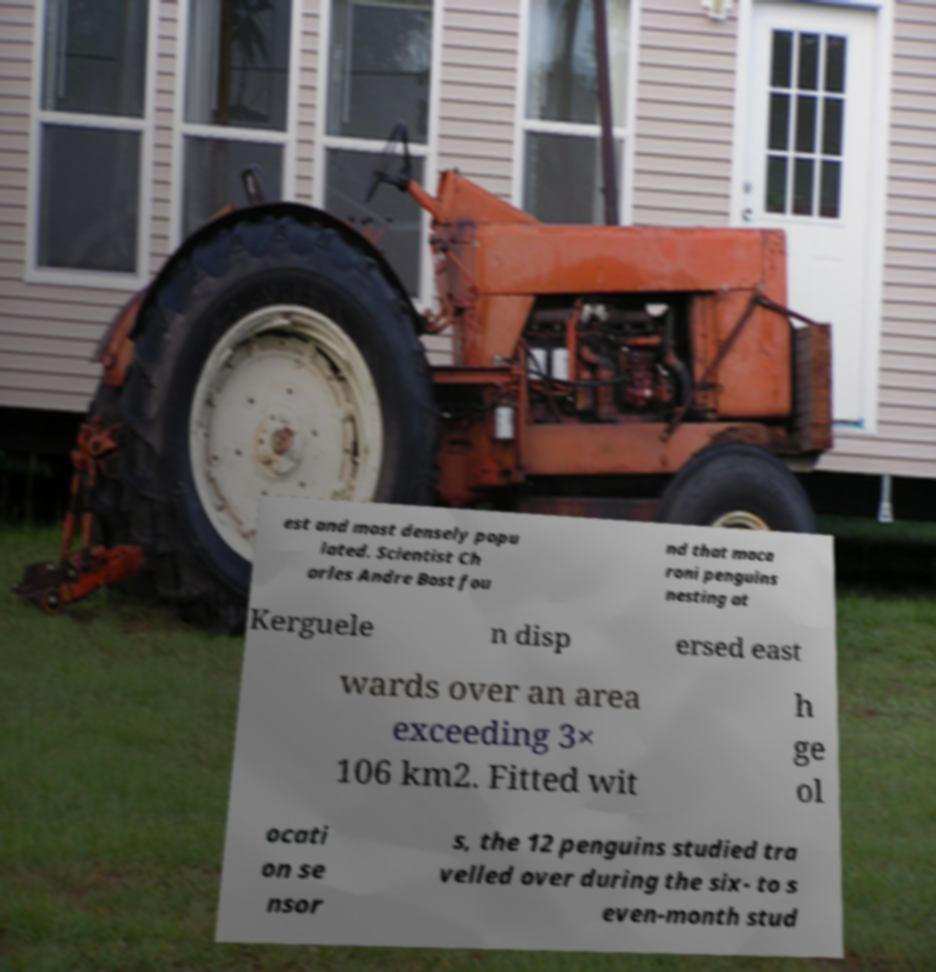Can you read and provide the text displayed in the image?This photo seems to have some interesting text. Can you extract and type it out for me? est and most densely popu lated. Scientist Ch arles Andre Bost fou nd that maca roni penguins nesting at Kerguele n disp ersed east wards over an area exceeding 3× 106 km2. Fitted wit h ge ol ocati on se nsor s, the 12 penguins studied tra velled over during the six- to s even-month stud 